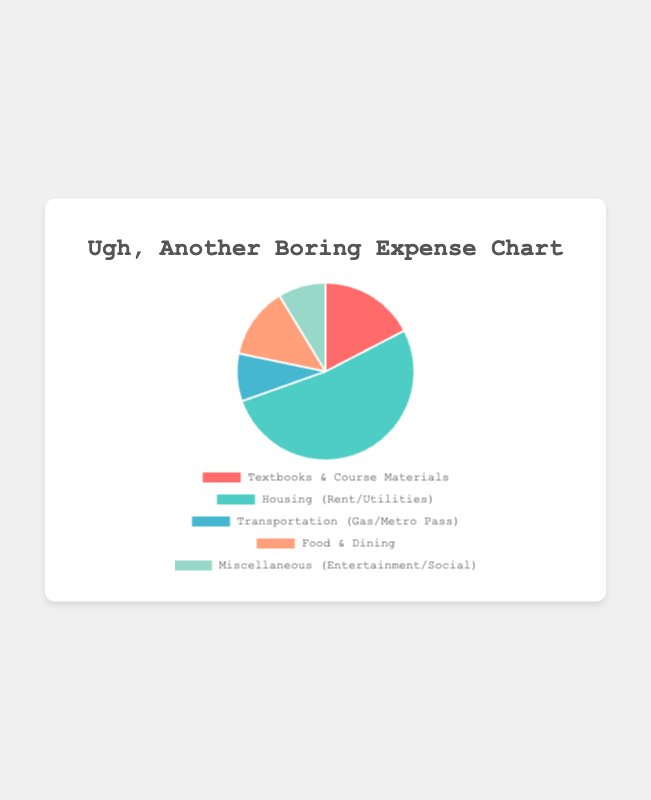What's the category with the highest expense? The pie chart shows the breakdown of expenses by category, and "Housing (Rent/Utilities)" takes up the largest slice. Therefore, it's the category with the highest expense.
Answer: Housing (Rent/Utilities) Which categories have the same amount of expenses? By examining the pie chart, "Transportation (Gas/Metro Pass)" and "Miscellaneous (Entertainment/Social)" both occupy the same size slice. Therefore, they have the same expense amount.
Answer: Transportation (Gas/Metro Pass), Miscellaneous (Entertainment/Social) What percentage of the total expenses is spent on Food & Dining? To calculate the percentage, divide the amount spent on "Food & Dining" by the total expenses and then multiply by 100. The total amount is 200 + 600 + 100 + 150 + 100 = 1150, and the amount for Food & Dining is 150. So, (150/1150) * 100 ≈ 13.04%.
Answer: 13.04% How much more is spent on Housing than Textbooks & Course Materials? Subtract the amount spent on Textbooks & Course Materials from the amount spent on Housing. Housing is $600, Textbooks & Course Materials is $200. So, 600 - 200 = 400.
Answer: $400 Which category represents the smallest portion of the expenses visually? "Transportation (Gas/Metro Pass)" and "Miscellaneous (Entertainment/Social)" both have the smallest slices in the pie chart, but since they are mentioned to be equal, either can be considered the smallest visually.
Answer: Transportation (Gas/Metro Pass) or Miscellaneous (Entertainment/Social) What's the combined expense for Textbooks & Course Materials and Food & Dining? Add the expenses of Textbooks & Course Materials and Food & Dining. Textbooks & Course Materials is $200, and Food & Dining is $150. So, 200 + 150 = 350.
Answer: $350 If the total expenses were reduced by $100, what would be the new percentage of the total expenses for Housing? First, calculate the new total expenses: 1150 - 100 = 1050. Then, divide the Housing expense by the new total and multiply by 100: (600/1050) * 100 ≈ 57.14%.
Answer: 57.14% How much more is spent on Housing than Transportation and Miscellaneous combined? First, add the expenses for Transportation and Miscellaneous: 100 (Transportation) + 100 (Miscellaneous) = 200. Then, subtract this combination from Housing: 600 - 200 = 400.
Answer: $400 What is the exact amount spent on Miscellaneous based on the chart? The chart shows each category's specific expense amounts, and for Miscellaneous it is indicated as $100.
Answer: $100 How does the expense on Food & Dining compare to the expense on Transportation? Comparing the two amounts, Food & Dining has a larger slice and expense amount than Transportation as Food & Dining is $150 and Transportation is $100.
Answer: Food & Dining is more than Transportation 